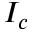Convert formula to latex. <formula><loc_0><loc_0><loc_500><loc_500>I _ { c }</formula> 